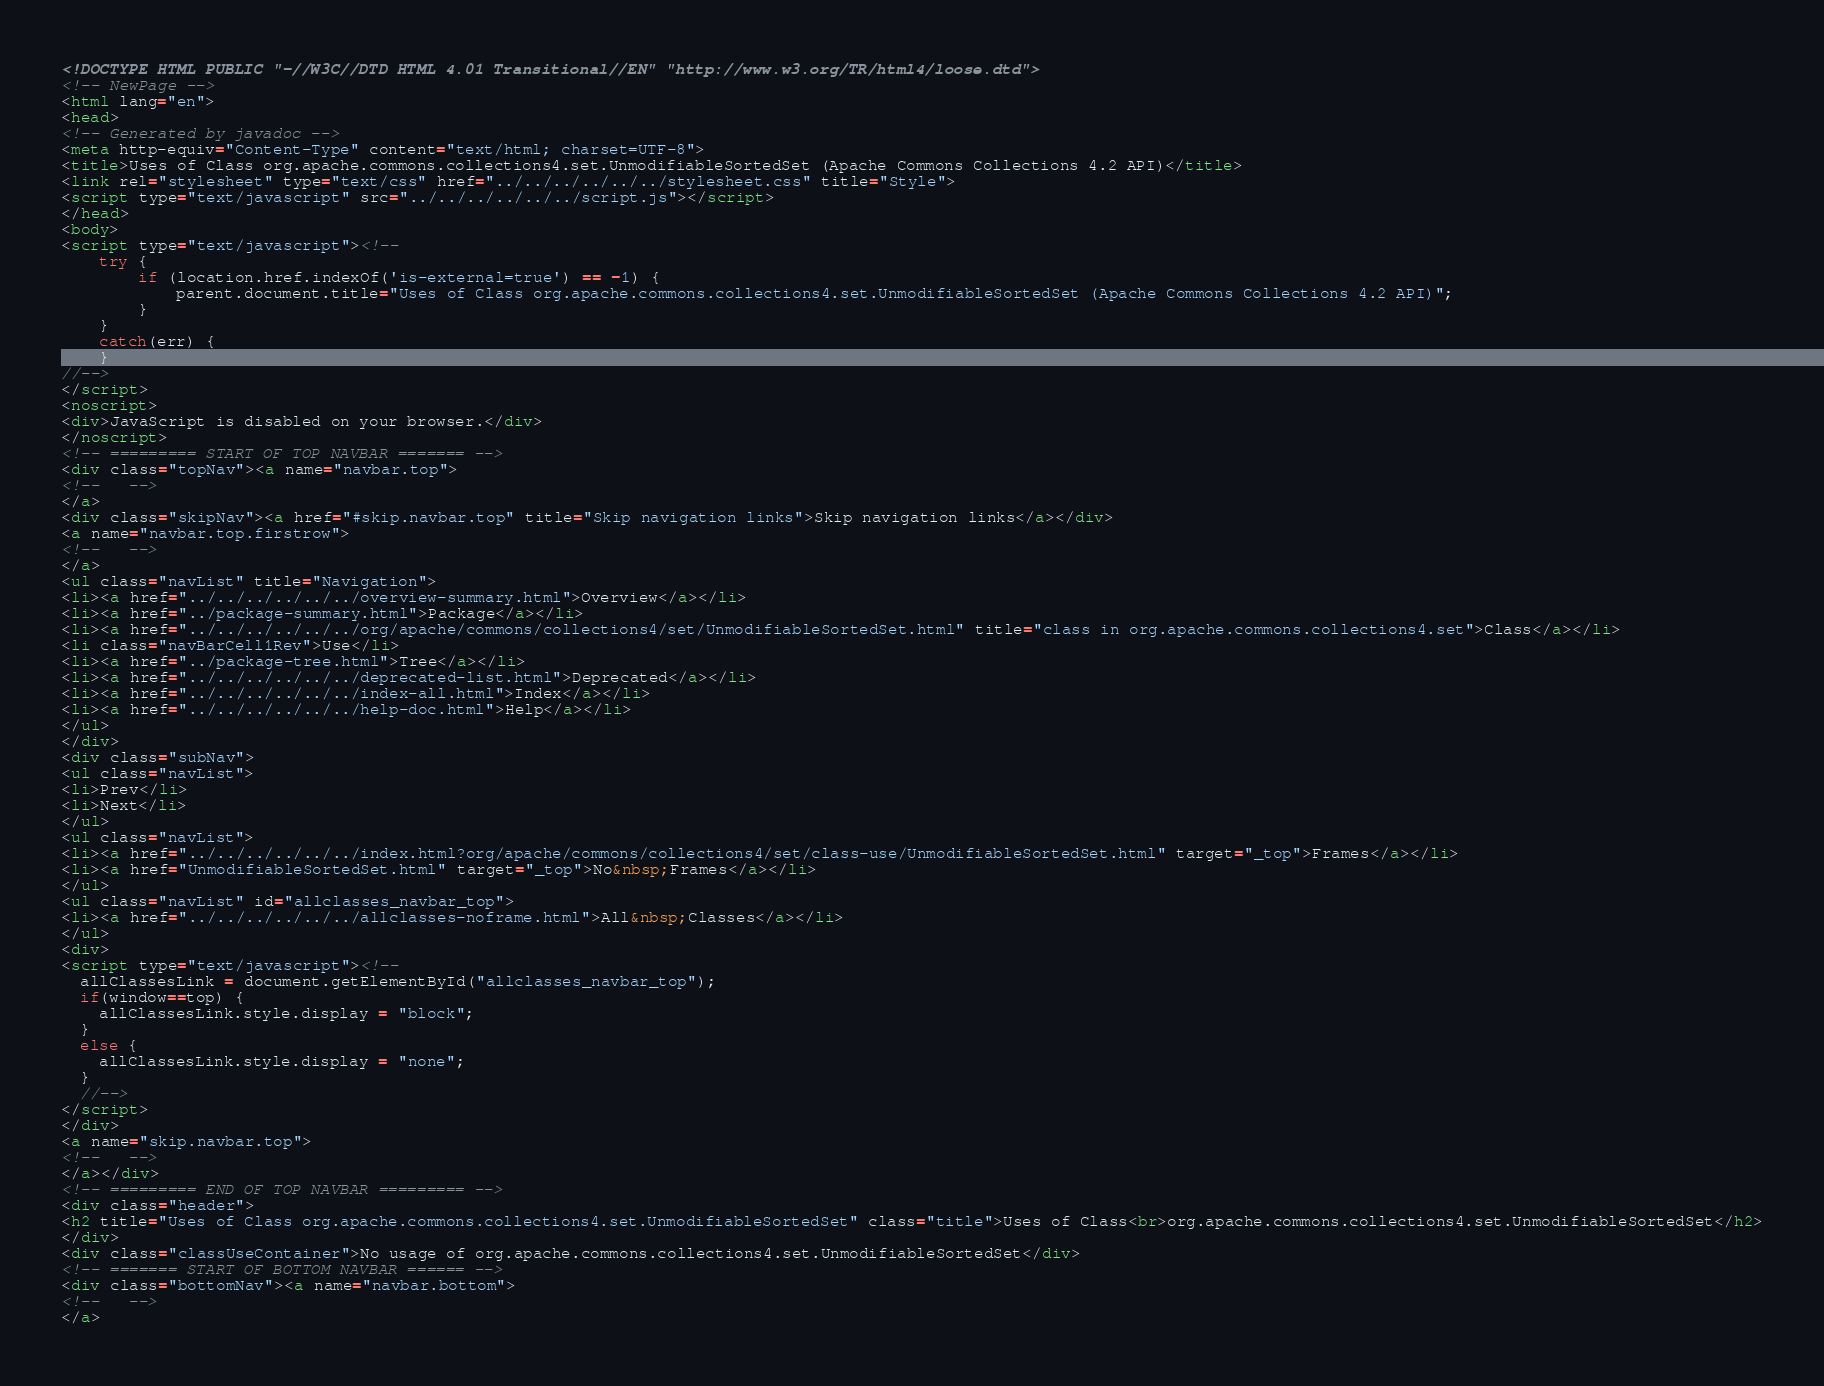<code> <loc_0><loc_0><loc_500><loc_500><_HTML_><!DOCTYPE HTML PUBLIC "-//W3C//DTD HTML 4.01 Transitional//EN" "http://www.w3.org/TR/html4/loose.dtd">
<!-- NewPage -->
<html lang="en">
<head>
<!-- Generated by javadoc -->
<meta http-equiv="Content-Type" content="text/html; charset=UTF-8">
<title>Uses of Class org.apache.commons.collections4.set.UnmodifiableSortedSet (Apache Commons Collections 4.2 API)</title>
<link rel="stylesheet" type="text/css" href="../../../../../../stylesheet.css" title="Style">
<script type="text/javascript" src="../../../../../../script.js"></script>
</head>
<body>
<script type="text/javascript"><!--
    try {
        if (location.href.indexOf('is-external=true') == -1) {
            parent.document.title="Uses of Class org.apache.commons.collections4.set.UnmodifiableSortedSet (Apache Commons Collections 4.2 API)";
        }
    }
    catch(err) {
    }
//-->
</script>
<noscript>
<div>JavaScript is disabled on your browser.</div>
</noscript>
<!-- ========= START OF TOP NAVBAR ======= -->
<div class="topNav"><a name="navbar.top">
<!--   -->
</a>
<div class="skipNav"><a href="#skip.navbar.top" title="Skip navigation links">Skip navigation links</a></div>
<a name="navbar.top.firstrow">
<!--   -->
</a>
<ul class="navList" title="Navigation">
<li><a href="../../../../../../overview-summary.html">Overview</a></li>
<li><a href="../package-summary.html">Package</a></li>
<li><a href="../../../../../../org/apache/commons/collections4/set/UnmodifiableSortedSet.html" title="class in org.apache.commons.collections4.set">Class</a></li>
<li class="navBarCell1Rev">Use</li>
<li><a href="../package-tree.html">Tree</a></li>
<li><a href="../../../../../../deprecated-list.html">Deprecated</a></li>
<li><a href="../../../../../../index-all.html">Index</a></li>
<li><a href="../../../../../../help-doc.html">Help</a></li>
</ul>
</div>
<div class="subNav">
<ul class="navList">
<li>Prev</li>
<li>Next</li>
</ul>
<ul class="navList">
<li><a href="../../../../../../index.html?org/apache/commons/collections4/set/class-use/UnmodifiableSortedSet.html" target="_top">Frames</a></li>
<li><a href="UnmodifiableSortedSet.html" target="_top">No&nbsp;Frames</a></li>
</ul>
<ul class="navList" id="allclasses_navbar_top">
<li><a href="../../../../../../allclasses-noframe.html">All&nbsp;Classes</a></li>
</ul>
<div>
<script type="text/javascript"><!--
  allClassesLink = document.getElementById("allclasses_navbar_top");
  if(window==top) {
    allClassesLink.style.display = "block";
  }
  else {
    allClassesLink.style.display = "none";
  }
  //-->
</script>
</div>
<a name="skip.navbar.top">
<!--   -->
</a></div>
<!-- ========= END OF TOP NAVBAR ========= -->
<div class="header">
<h2 title="Uses of Class org.apache.commons.collections4.set.UnmodifiableSortedSet" class="title">Uses of Class<br>org.apache.commons.collections4.set.UnmodifiableSortedSet</h2>
</div>
<div class="classUseContainer">No usage of org.apache.commons.collections4.set.UnmodifiableSortedSet</div>
<!-- ======= START OF BOTTOM NAVBAR ====== -->
<div class="bottomNav"><a name="navbar.bottom">
<!--   -->
</a></code> 